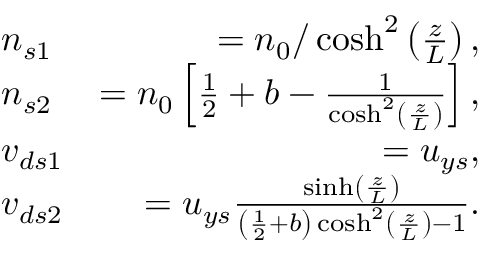Convert formula to latex. <formula><loc_0><loc_0><loc_500><loc_500>\begin{array} { r l r } & { n _ { s 1 } } & { = n _ { 0 } / \cosh ^ { 2 } \left ( \frac { z } { L } \right ) , } \\ & { n _ { s 2 } } & { = n _ { 0 } \left [ \frac { 1 } { 2 } + b - \frac { 1 } { \cosh ^ { 2 } \left ( \frac { z } { L } \right ) } \right ] , } \\ & { v _ { d s 1 } } & { = u _ { y s } , } \\ & { v _ { d s 2 } } & { = u _ { y s } \frac { \sinh \left ( \frac { z } { L } \right ) } { \left ( \frac { 1 } { 2 } + b \right ) \cosh ^ { 2 } \left ( \frac { z } { L } \right ) - 1 } . } \end{array}</formula> 